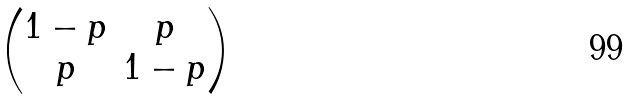<formula> <loc_0><loc_0><loc_500><loc_500>\begin{pmatrix} 1 - p & p \\ p & 1 - p \\ \end{pmatrix}</formula> 